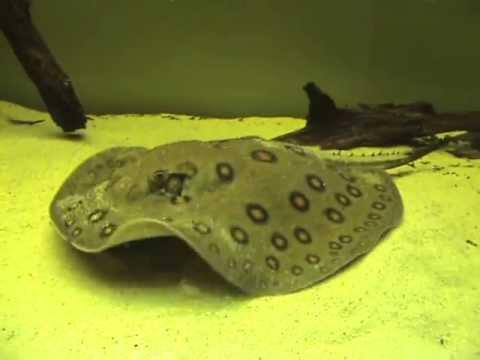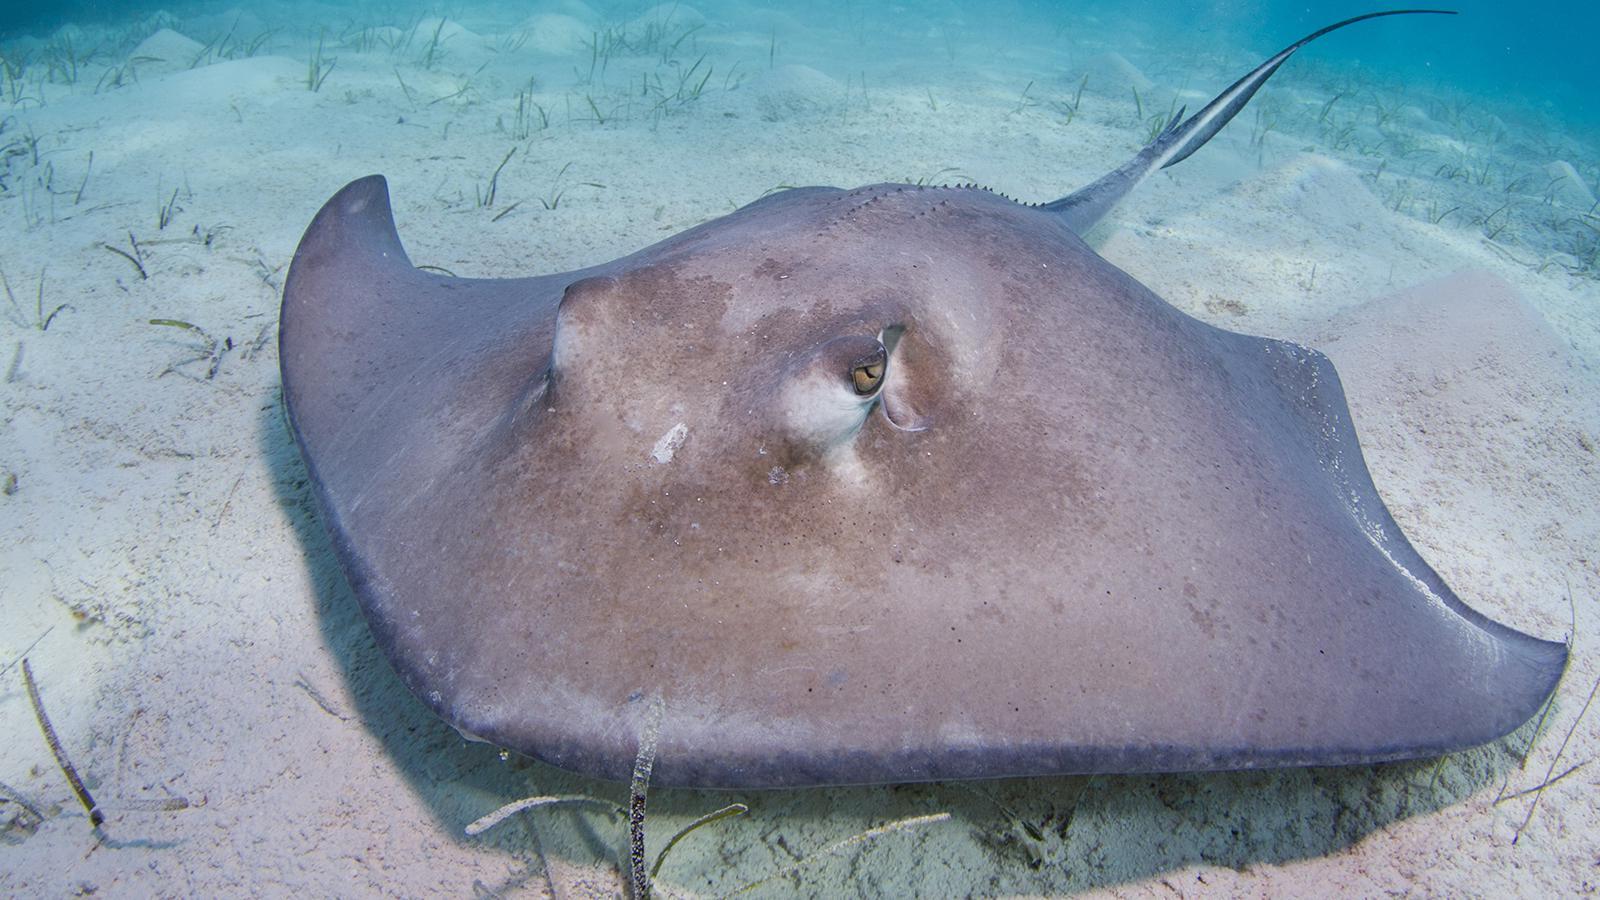The first image is the image on the left, the second image is the image on the right. For the images displayed, is the sentence "All stingrays shown have distinctive colorful dot patterns." factually correct? Answer yes or no. No. 